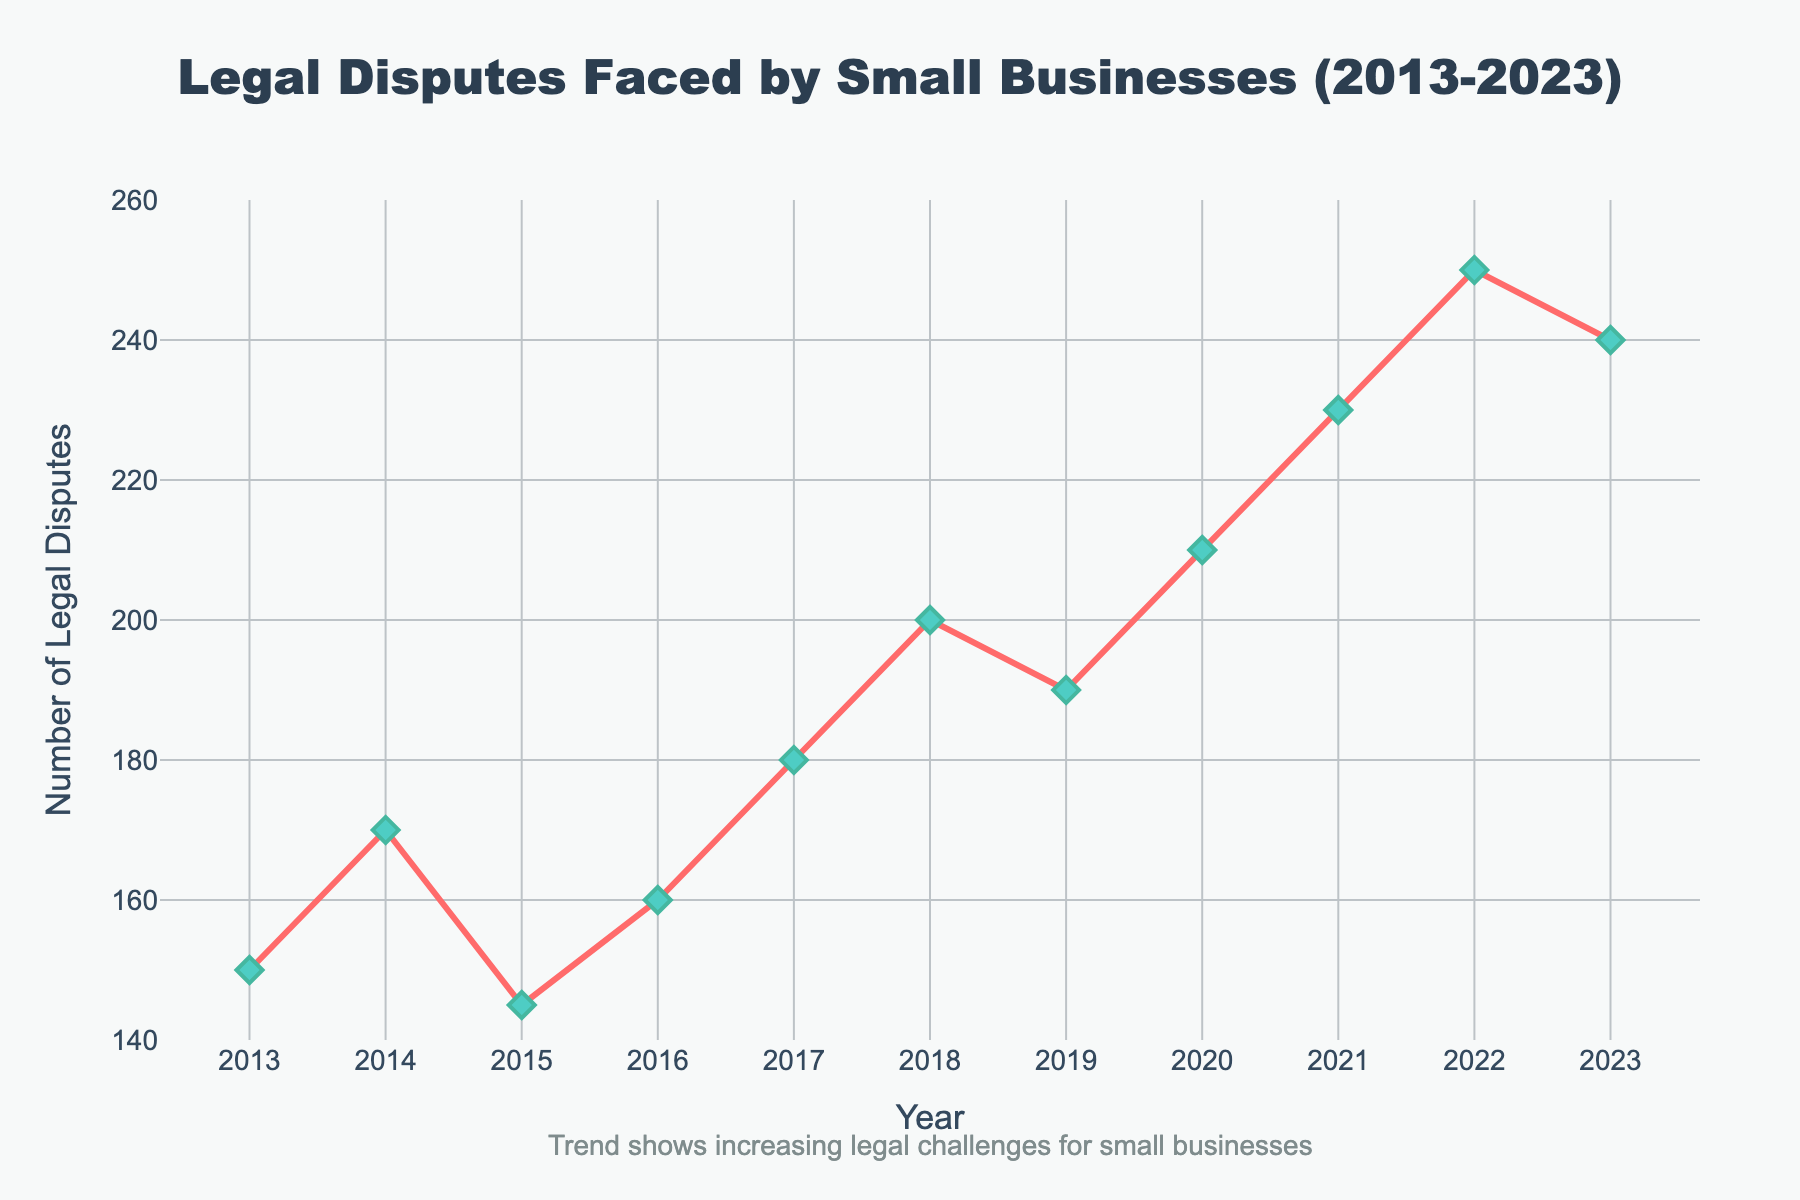What is the title of the figure? The title is located at the top of the figure and provides an overview of the plot's content. The title is: "Legal Disputes Faced by Small Businesses (2013-2023)"
Answer: Legal Disputes Faced by Small Businesses (2013-2023) How many data points are shown in the figure? Each data point represents a year, ranging from 2013 to 2023. Counting these points gives a total of 11 data points.
Answer: 11 Which year had the highest number of legal disputes? Look at the y-axis values and identify the peak point. The highest value is 250, which occurs in the year 2022.
Answer: 2022 What is the number of legal disputes faced by small businesses in 2015? Locate the x-axis value for 2015 and check the corresponding y-axis value. For 2015, the number of legal disputes is 145.
Answer: 145 What is the average number of legal disputes from 2013 to 2023? Sum all the values and divide by the number of years (11). Sum = 150 + 170 + 145 + 160 + 180 + 200 + 190 + 210 + 230 + 250 + 240 = 2125. Average = 2125 / 11.
Answer: 193.18 How much did the number of legal disputes increase from 2015 to 2022? Locate the values for 2015 (145) and 2022 (250), then subtract the 2015 value from 2022. Increase = 250 - 145.
Answer: 105 In which years did the number of legal disputes exceed 200? Identify the points where the y-axis values are greater than 200. These years are 2020, 2021, 2022, and 2023.
Answer: 2020, 2021, 2022, 2023 What is the trend of the number of legal disputes over the decade? Analyze the general direction of the data points. The trend shows an increase in the number of legal disputes from 2013 to 2023.
Answer: Increasing trend What is the difference in the number of legal disputes between the years 2018 and 2019? Identify the values for 2018 (200) and 2019 (190), then subtract the 2019 value from 2018. Difference = 200 - 190.
Answer: 10 How does the number of legal disputes in 2020 compare to that in 2023? Identify the values for 2020 (210) and 2023 (240). Since 240 is greater than 210, the number of disputes in 2023 is higher.
Answer: Higher in 2023 